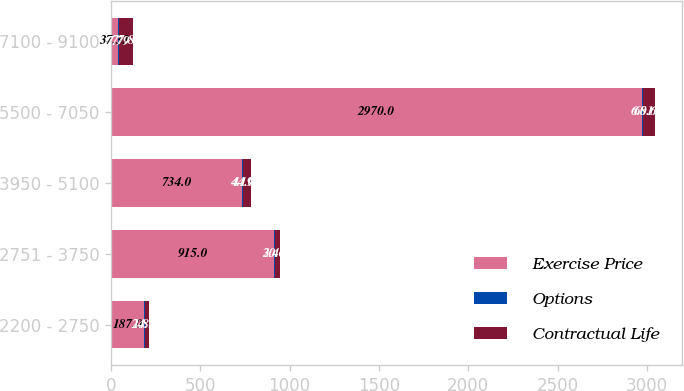<chart> <loc_0><loc_0><loc_500><loc_500><stacked_bar_chart><ecel><fcel>2200 - 2750<fcel>2751 - 3750<fcel>3950 - 5100<fcel>5500 - 7050<fcel>7100 - 9100<nl><fcel>Exercise Price<fcel>187<fcel>915<fcel>734<fcel>2970<fcel>37.33<nl><fcel>Options<fcel>1.85<fcel>2.46<fcel>4.19<fcel>6.01<fcel>7.79<nl><fcel>Contractual Life<fcel>24.76<fcel>30.64<fcel>44.02<fcel>68.64<fcel>77.88<nl></chart> 